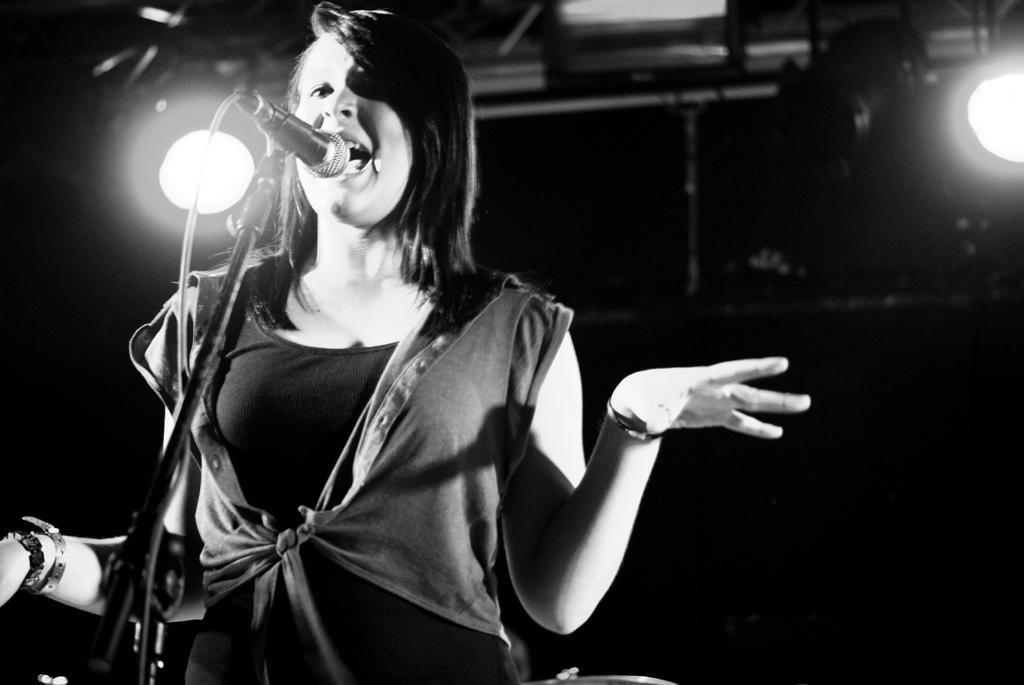How would you summarize this image in a sentence or two? In the picture there is a woman standing in front of a microphone, behind her there are lights present. 